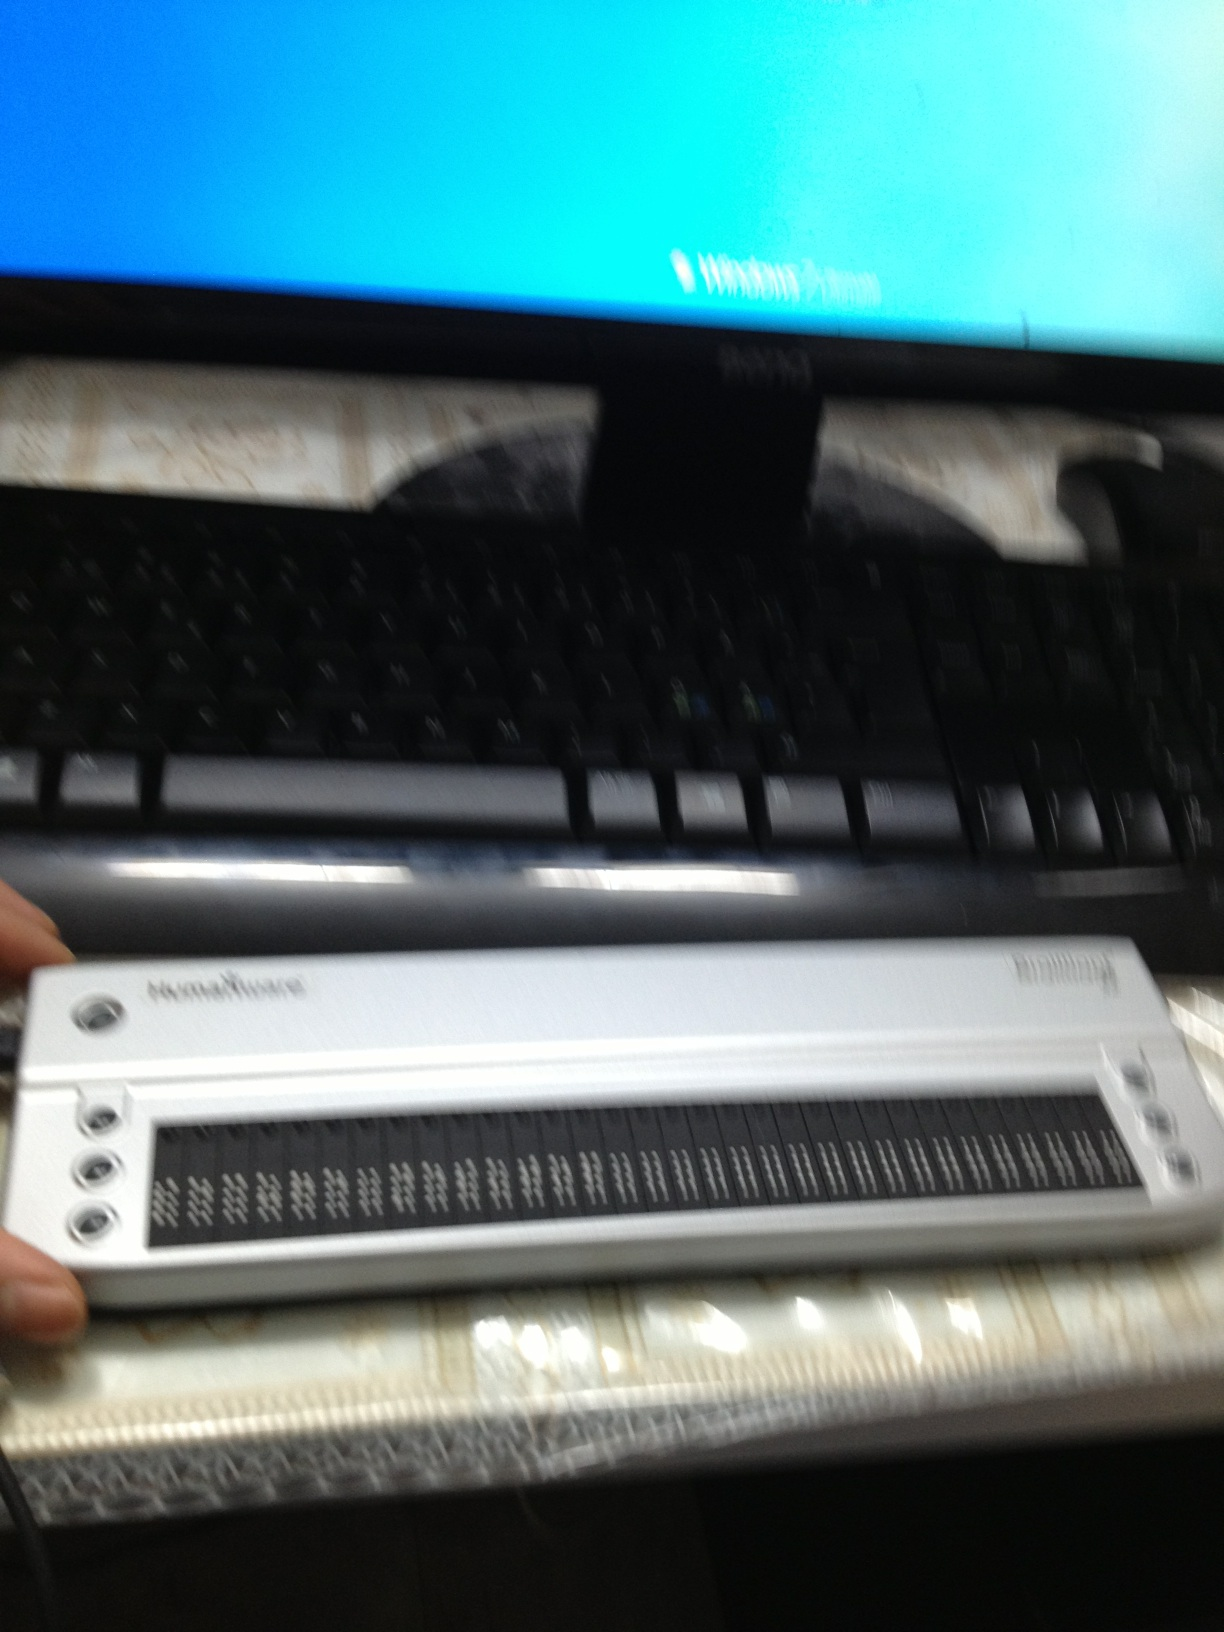Imagine the person using this setup is working on a critical project. Describe their scenario. Alex, a cybersecurity expert, sat at their desk, the faint hum of the computer their constant companion. With fingers gliding over the refreshable braille display, they navigated complex encryption algorithms with ease. The screen displayed lines of code, but Alex needed to feel the structure in braille to identify patterns. A massive cyber-attack threatened national security, and Alex's quick thinking and unique abilities were the last line of defense. Hours turned into moments as they decoded the threat, piecing together the attack's origin and neutralizing it just in time to prevent a catastrophe. 